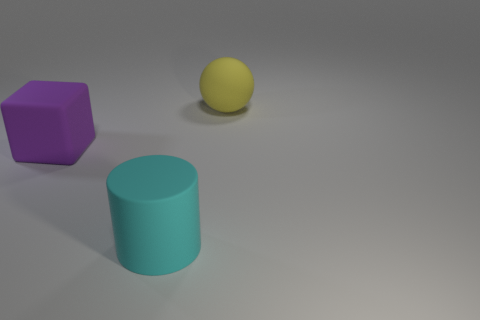Add 2 purple matte objects. How many objects exist? 5 Subtract all cylinders. How many objects are left? 2 Subtract 1 cubes. How many cubes are left? 0 Subtract all purple cubes. How many red spheres are left? 0 Subtract all gray balls. Subtract all brown cubes. How many balls are left? 1 Subtract all large red rubber objects. Subtract all big matte objects. How many objects are left? 0 Add 1 matte spheres. How many matte spheres are left? 2 Add 3 big cyan shiny things. How many big cyan shiny things exist? 3 Subtract 0 gray spheres. How many objects are left? 3 